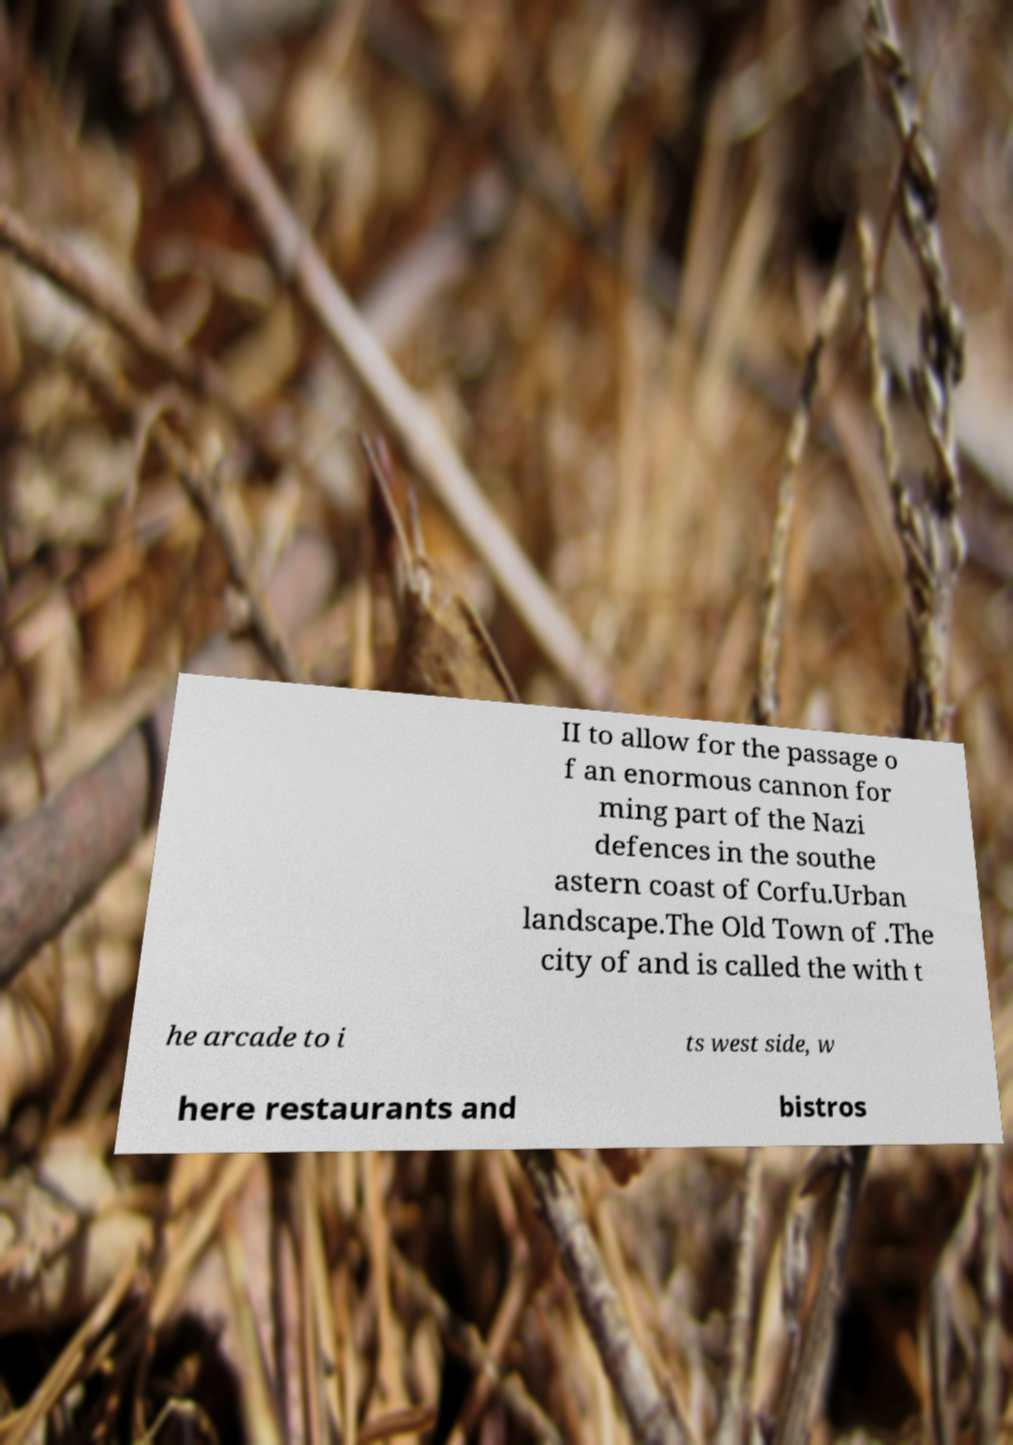For documentation purposes, I need the text within this image transcribed. Could you provide that? II to allow for the passage o f an enormous cannon for ming part of the Nazi defences in the southe astern coast of Corfu.Urban landscape.The Old Town of .The city of and is called the with t he arcade to i ts west side, w here restaurants and bistros 